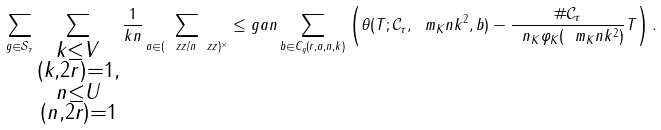Convert formula to latex. <formula><loc_0><loc_0><loc_500><loc_500>\sum _ { g \in \mathcal { S } _ { \tau } } \sum _ { \substack { k \leq V \\ ( k , 2 r ) = 1 , \\ n \leq U \\ ( n , 2 r ) = 1 } } \frac { 1 } { k n } \sum _ { a \in ( \ z z / n \ z z ) ^ { \times } } \leq g { a } { n } \sum _ { b \in C _ { g } ( r , a , n , k ) } \left ( \theta ( T ; \mathcal { C } _ { \tau } , \ m _ { K } n k ^ { 2 } , b ) - \frac { \# \mathcal { C } _ { \tau } } { \ n _ { K } \varphi _ { K } ( \ m _ { K } n k ^ { 2 } ) } T \right ) .</formula> 